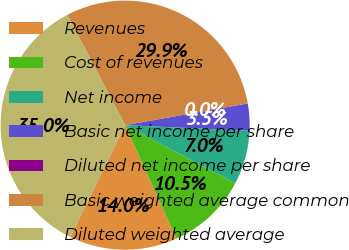Convert chart to OTSL. <chart><loc_0><loc_0><loc_500><loc_500><pie_chart><fcel>Revenues<fcel>Cost of revenues<fcel>Net income<fcel>Basic net income per share<fcel>Diluted net income per share<fcel>Basic weighted average common<fcel>Diluted weighted average<nl><fcel>14.02%<fcel>10.52%<fcel>7.01%<fcel>3.51%<fcel>0.0%<fcel>29.89%<fcel>35.05%<nl></chart> 